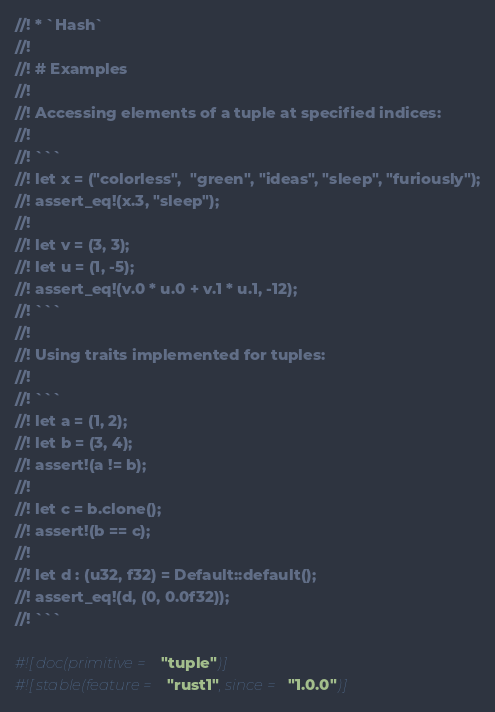<code> <loc_0><loc_0><loc_500><loc_500><_Rust_>//! * `Hash`
//!
//! # Examples
//!
//! Accessing elements of a tuple at specified indices:
//!
//! ```
//! let x = ("colorless",  "green", "ideas", "sleep", "furiously");
//! assert_eq!(x.3, "sleep");
//!
//! let v = (3, 3);
//! let u = (1, -5);
//! assert_eq!(v.0 * u.0 + v.1 * u.1, -12);
//! ```
//!
//! Using traits implemented for tuples:
//!
//! ```
//! let a = (1, 2);
//! let b = (3, 4);
//! assert!(a != b);
//!
//! let c = b.clone();
//! assert!(b == c);
//!
//! let d : (u32, f32) = Default::default();
//! assert_eq!(d, (0, 0.0f32));
//! ```

#![doc(primitive = "tuple")]
#![stable(feature = "rust1", since = "1.0.0")]
</code> 